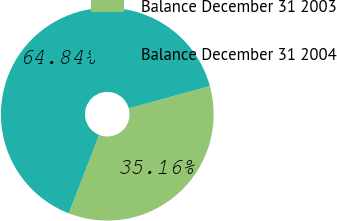Convert chart. <chart><loc_0><loc_0><loc_500><loc_500><pie_chart><fcel>Balance December 31 2003<fcel>Balance December 31 2004<nl><fcel>35.16%<fcel>64.84%<nl></chart> 